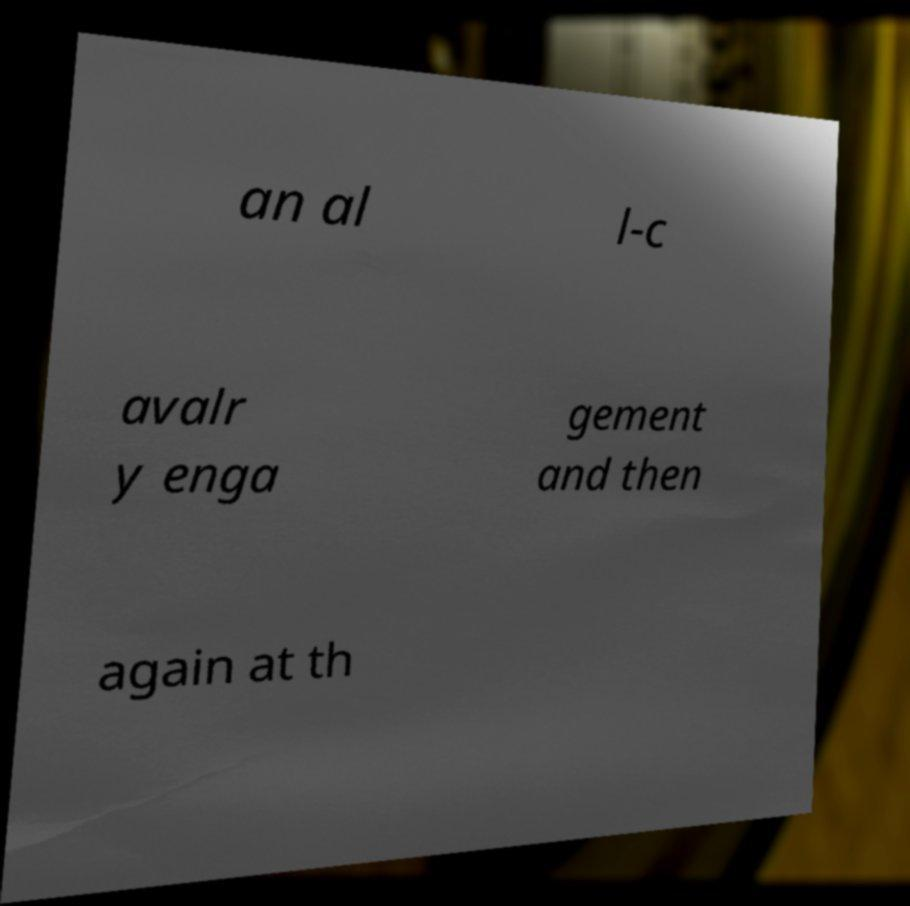What messages or text are displayed in this image? I need them in a readable, typed format. an al l-c avalr y enga gement and then again at th 